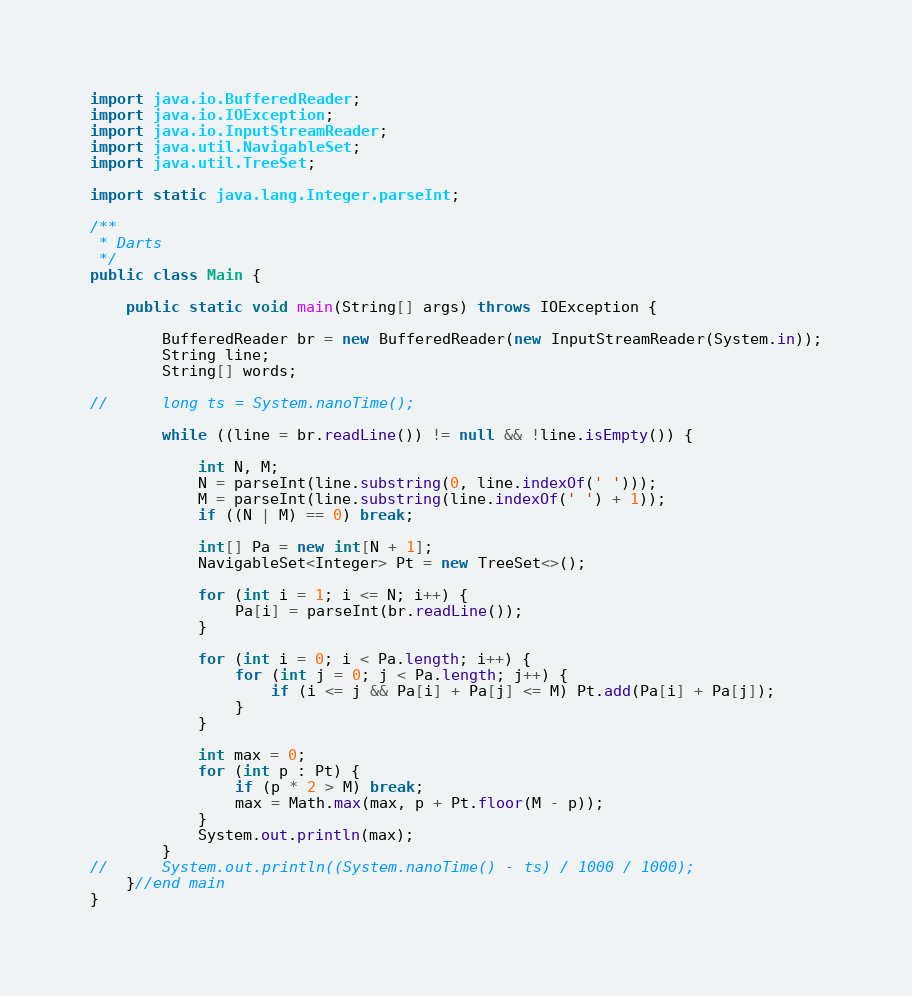Convert code to text. <code><loc_0><loc_0><loc_500><loc_500><_Java_>import java.io.BufferedReader;
import java.io.IOException;
import java.io.InputStreamReader;
import java.util.NavigableSet;
import java.util.TreeSet;

import static java.lang.Integer.parseInt;

/**
 * Darts
 */
public class Main {

	public static void main(String[] args) throws IOException {

		BufferedReader br = new BufferedReader(new InputStreamReader(System.in));
		String line;
		String[] words;

//		long ts = System.nanoTime();

		while ((line = br.readLine()) != null && !line.isEmpty()) {

			int N, M;
			N = parseInt(line.substring(0, line.indexOf(' ')));
			M = parseInt(line.substring(line.indexOf(' ') + 1));
			if ((N | M) == 0) break;

			int[] Pa = new int[N + 1];
			NavigableSet<Integer> Pt = new TreeSet<>();

			for (int i = 1; i <= N; i++) {
				Pa[i] = parseInt(br.readLine());
			}

			for (int i = 0; i < Pa.length; i++) {
				for (int j = 0; j < Pa.length; j++) {
					if (i <= j && Pa[i] + Pa[j] <= M) Pt.add(Pa[i] + Pa[j]);
				}
			}

			int max = 0;
			for (int p : Pt) {
				if (p * 2 > M) break;
				max = Math.max(max, p + Pt.floor(M - p));
			}
			System.out.println(max);
		}
//		System.out.println((System.nanoTime() - ts) / 1000 / 1000);
	}//end main
}</code> 